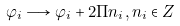Convert formula to latex. <formula><loc_0><loc_0><loc_500><loc_500>\varphi _ { i } \longrightarrow \varphi _ { i } + 2 \Pi n _ { i } , n _ { i } \in Z</formula> 